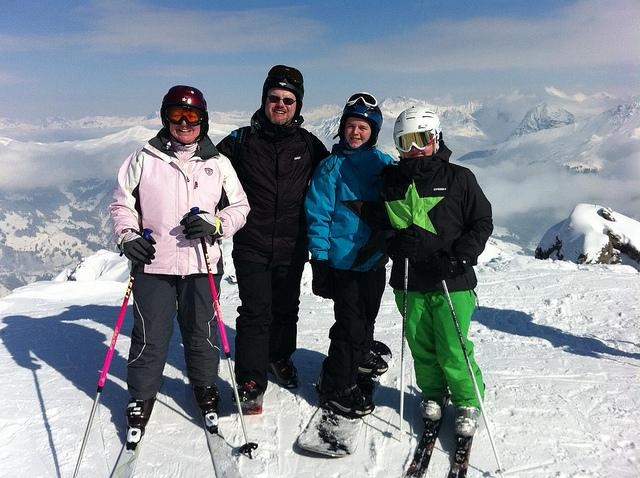What is a country that is famously a host to this sport? Please explain your reasoning. switzerland. The country is switzerland. 